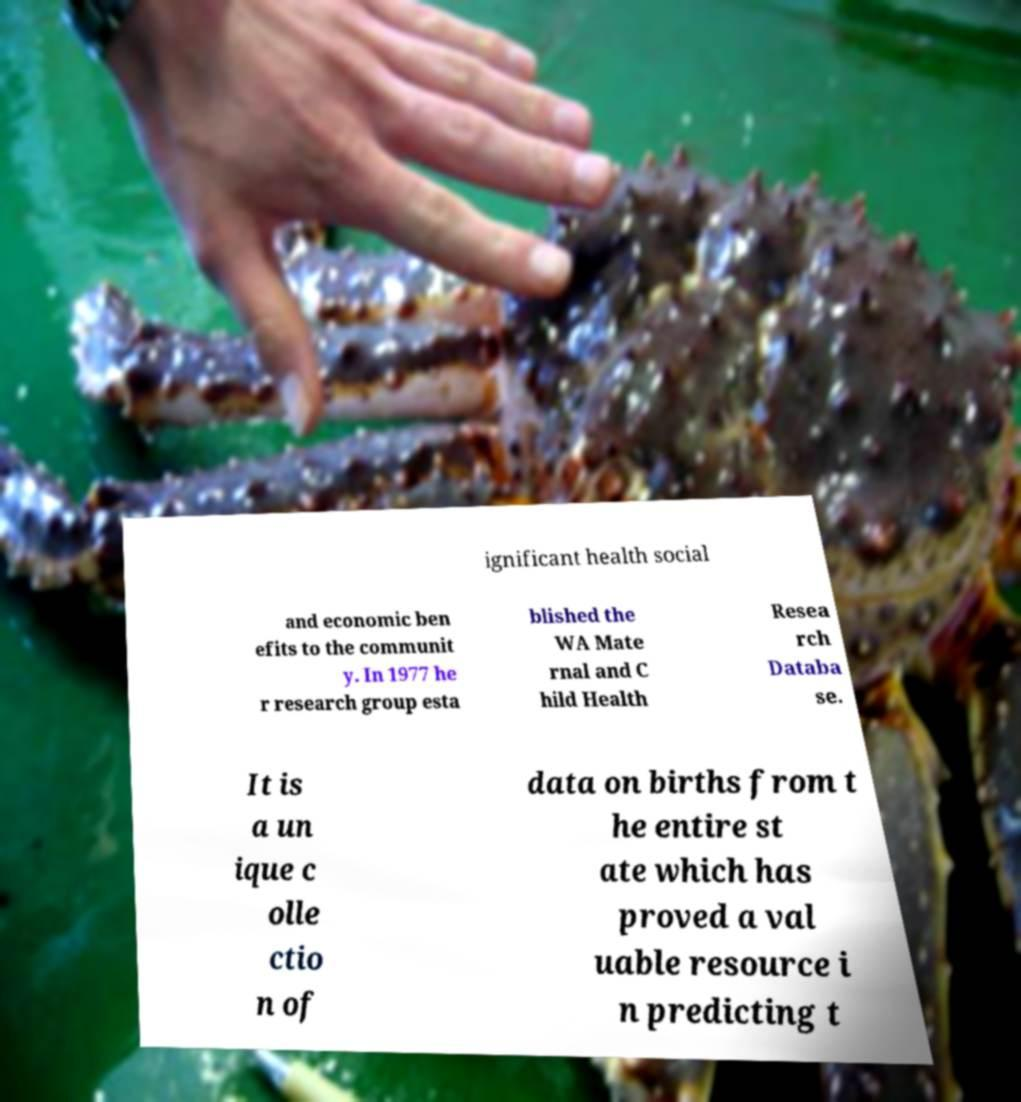Can you read and provide the text displayed in the image?This photo seems to have some interesting text. Can you extract and type it out for me? ignificant health social and economic ben efits to the communit y. In 1977 he r research group esta blished the WA Mate rnal and C hild Health Resea rch Databa se. It is a un ique c olle ctio n of data on births from t he entire st ate which has proved a val uable resource i n predicting t 